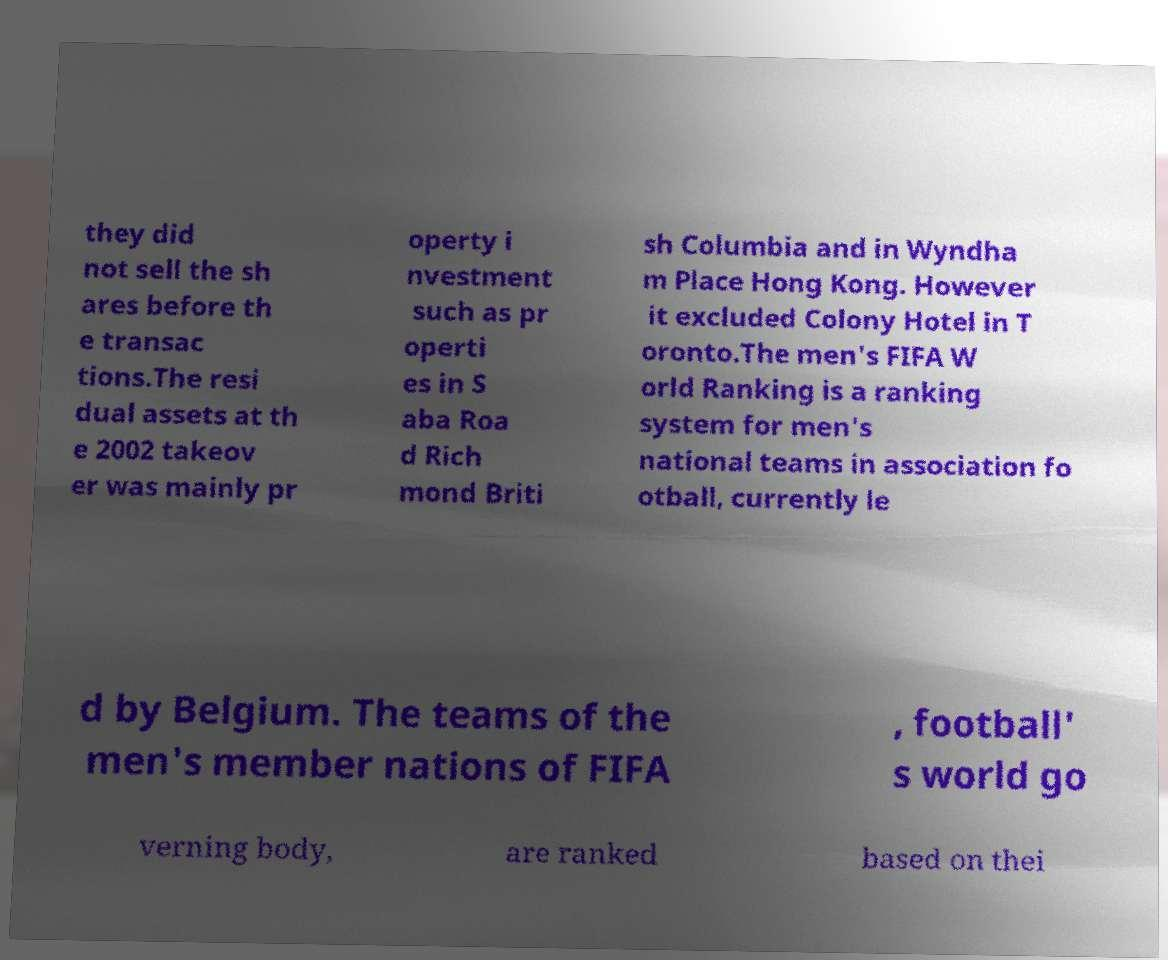Can you read and provide the text displayed in the image?This photo seems to have some interesting text. Can you extract and type it out for me? they did not sell the sh ares before th e transac tions.The resi dual assets at th e 2002 takeov er was mainly pr operty i nvestment such as pr operti es in S aba Roa d Rich mond Briti sh Columbia and in Wyndha m Place Hong Kong. However it excluded Colony Hotel in T oronto.The men's FIFA W orld Ranking is a ranking system for men's national teams in association fo otball, currently le d by Belgium. The teams of the men's member nations of FIFA , football' s world go verning body, are ranked based on thei 